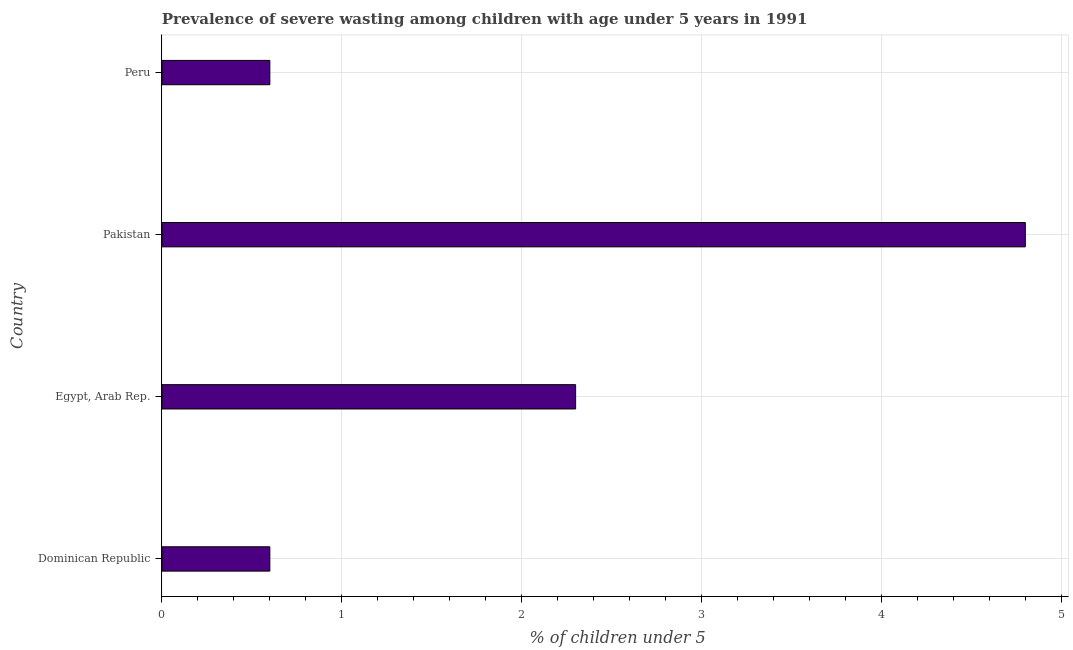Does the graph contain grids?
Provide a succinct answer. Yes. What is the title of the graph?
Keep it short and to the point. Prevalence of severe wasting among children with age under 5 years in 1991. What is the label or title of the X-axis?
Offer a very short reply.  % of children under 5. What is the prevalence of severe wasting in Dominican Republic?
Ensure brevity in your answer.  0.6. Across all countries, what is the maximum prevalence of severe wasting?
Offer a very short reply. 4.8. Across all countries, what is the minimum prevalence of severe wasting?
Keep it short and to the point. 0.6. In which country was the prevalence of severe wasting minimum?
Your answer should be compact. Dominican Republic. What is the sum of the prevalence of severe wasting?
Provide a short and direct response. 8.3. What is the difference between the prevalence of severe wasting in Dominican Republic and Peru?
Ensure brevity in your answer.  0. What is the average prevalence of severe wasting per country?
Your answer should be very brief. 2.08. What is the median prevalence of severe wasting?
Your answer should be compact. 1.45. What is the ratio of the prevalence of severe wasting in Egypt, Arab Rep. to that in Peru?
Make the answer very short. 3.83. Is the prevalence of severe wasting in Dominican Republic less than that in Pakistan?
Give a very brief answer. Yes. Is the difference between the prevalence of severe wasting in Dominican Republic and Pakistan greater than the difference between any two countries?
Your response must be concise. Yes. What is the difference between the highest and the lowest prevalence of severe wasting?
Your answer should be compact. 4.2. In how many countries, is the prevalence of severe wasting greater than the average prevalence of severe wasting taken over all countries?
Your response must be concise. 2. Are all the bars in the graph horizontal?
Ensure brevity in your answer.  Yes. What is the  % of children under 5 in Dominican Republic?
Give a very brief answer. 0.6. What is the  % of children under 5 of Egypt, Arab Rep.?
Your response must be concise. 2.3. What is the  % of children under 5 of Pakistan?
Offer a very short reply. 4.8. What is the  % of children under 5 of Peru?
Keep it short and to the point. 0.6. What is the difference between the  % of children under 5 in Dominican Republic and Egypt, Arab Rep.?
Offer a very short reply. -1.7. What is the ratio of the  % of children under 5 in Dominican Republic to that in Egypt, Arab Rep.?
Offer a terse response. 0.26. What is the ratio of the  % of children under 5 in Egypt, Arab Rep. to that in Pakistan?
Provide a short and direct response. 0.48. What is the ratio of the  % of children under 5 in Egypt, Arab Rep. to that in Peru?
Provide a short and direct response. 3.83. 